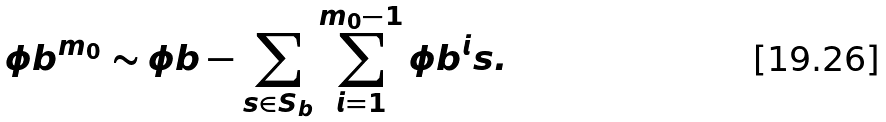Convert formula to latex. <formula><loc_0><loc_0><loc_500><loc_500>\phi b ^ { m _ { 0 } } \sim \phi b - \sum _ { s \in S _ { b } } \sum _ { i = 1 } ^ { m _ { 0 } - 1 } \phi b ^ { i } s .</formula> 